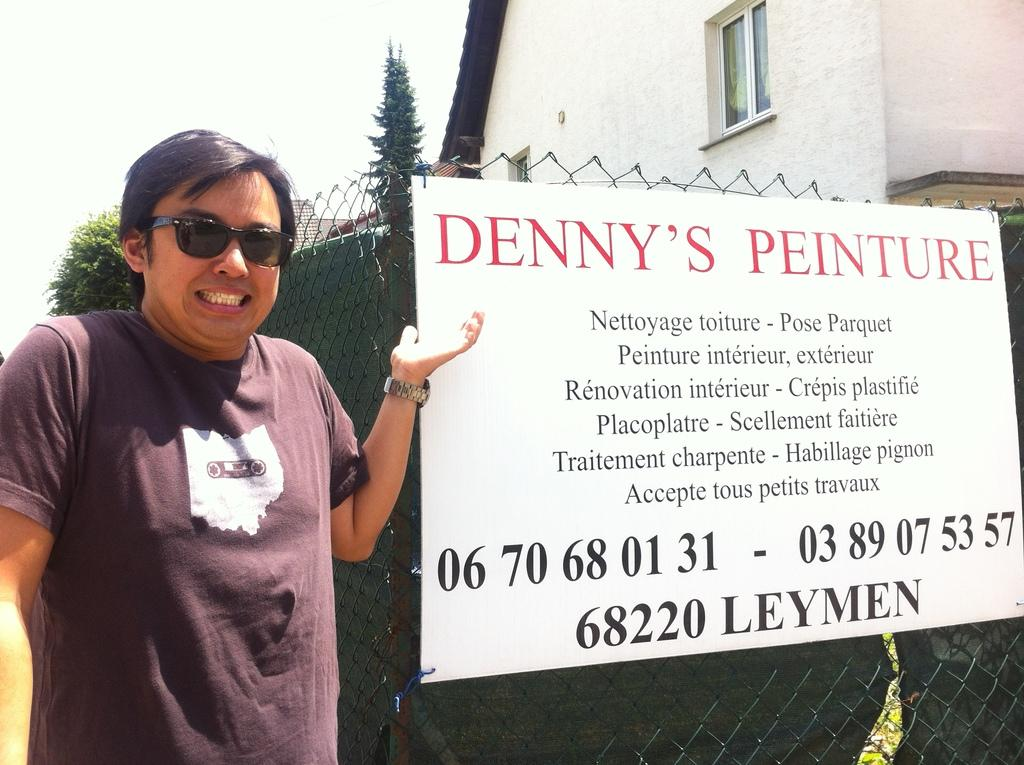What is the main subject in the image? There is a person standing in the image. What is attached to the mesh in the image? There is an advertising board attached to a mesh in the image. What type of structure can be seen in the image? There is a building in the image. What type of vegetation is present in the image? There are trees in the image. What part of the natural environment is visible in the image? The sky is visible in the image. How many girls are sitting on the wall in the image? There are no girls or walls present in the image. 